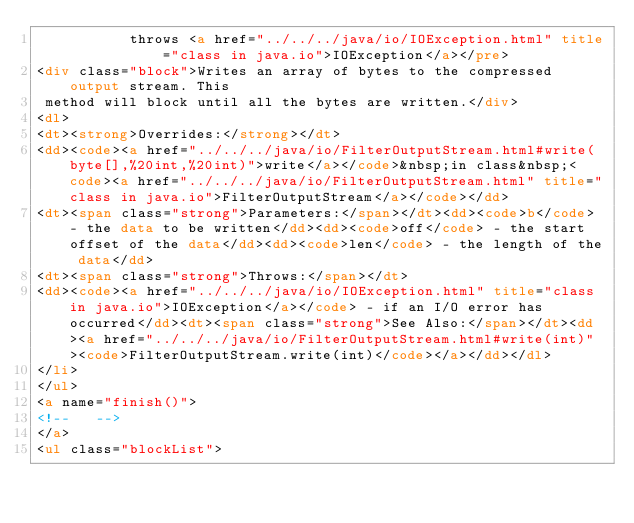<code> <loc_0><loc_0><loc_500><loc_500><_HTML_>           throws <a href="../../../java/io/IOException.html" title="class in java.io">IOException</a></pre>
<div class="block">Writes an array of bytes to the compressed output stream. This
 method will block until all the bytes are written.</div>
<dl>
<dt><strong>Overrides:</strong></dt>
<dd><code><a href="../../../java/io/FilterOutputStream.html#write(byte[],%20int,%20int)">write</a></code>&nbsp;in class&nbsp;<code><a href="../../../java/io/FilterOutputStream.html" title="class in java.io">FilterOutputStream</a></code></dd>
<dt><span class="strong">Parameters:</span></dt><dd><code>b</code> - the data to be written</dd><dd><code>off</code> - the start offset of the data</dd><dd><code>len</code> - the length of the data</dd>
<dt><span class="strong">Throws:</span></dt>
<dd><code><a href="../../../java/io/IOException.html" title="class in java.io">IOException</a></code> - if an I/O error has occurred</dd><dt><span class="strong">See Also:</span></dt><dd><a href="../../../java/io/FilterOutputStream.html#write(int)"><code>FilterOutputStream.write(int)</code></a></dd></dl>
</li>
</ul>
<a name="finish()">
<!--   -->
</a>
<ul class="blockList"></code> 